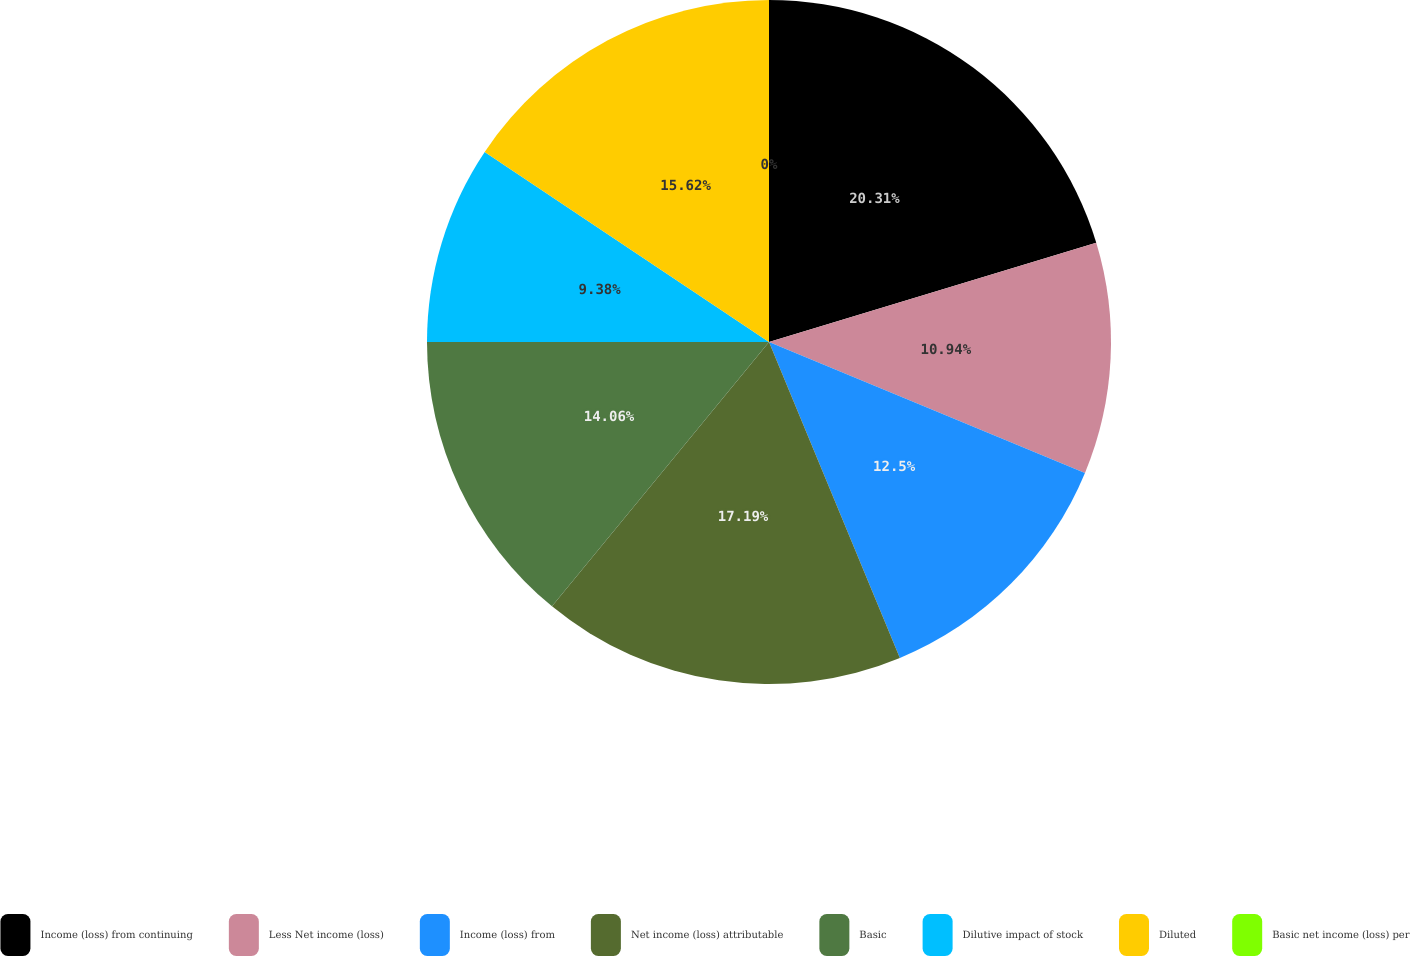Convert chart to OTSL. <chart><loc_0><loc_0><loc_500><loc_500><pie_chart><fcel>Income (loss) from continuing<fcel>Less Net income (loss)<fcel>Income (loss) from<fcel>Net income (loss) attributable<fcel>Basic<fcel>Dilutive impact of stock<fcel>Diluted<fcel>Basic net income (loss) per<nl><fcel>20.31%<fcel>10.94%<fcel>12.5%<fcel>17.19%<fcel>14.06%<fcel>9.38%<fcel>15.62%<fcel>0.0%<nl></chart> 